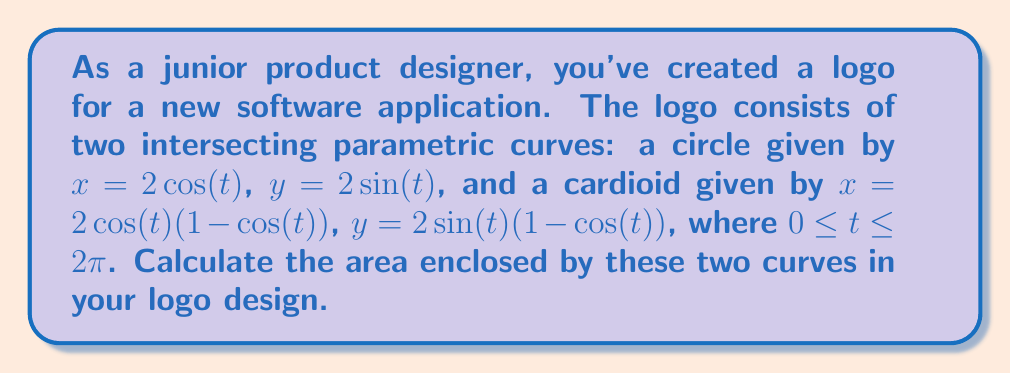Can you answer this question? To solve this problem, we'll follow these steps:

1) First, we need to find the points of intersection between the circle and the cardioid. These occur when:

   $2\cos(t) = 2\cos(t)(1-\cos(t))$
   $2\sin(t) = 2\sin(t)(1-\cos(t))$

   Solving these equations, we find that the curves intersect at $t = \frac{\pi}{3}$ and $t = \frac{5\pi}{3}$.

2) The area we're looking for is the difference between the area of the circle and the area of the cardioid that's outside the circle.

3) The area of the circle is straightforward:

   $A_{circle} = \pi r^2 = \pi(2^2) = 4\pi$

4) For the cardioid, we need to use the formula for area in polar coordinates:

   $A = \frac{1}{2} \int_0^{2\pi} r^2(\theta) d\theta$

   Where $r(\theta) = 2(1-\cos(\theta))$

5) Substituting this into our formula:

   $A_{cardioid} = \frac{1}{2} \int_0^{2\pi} (2(1-\cos(\theta)))^2 d\theta$
                 $= 2 \int_0^{2\pi} (1-2\cos(\theta)+\cos^2(\theta)) d\theta$
                 $= 2 [\theta - 2\sin(\theta) + \frac{\theta}{2} + \frac{\sin(2\theta)}{4}]_0^{2\pi}$
                 $= 2 [2\pi - 0 + \pi + 0] = 6\pi$

6) The area we want is the area of the circle minus the area of the cardioid outside the circle:

   $A_{logo} = A_{circle} + (A_{circle} - A_{cardioid})$
             $= 4\pi + (4\pi - 6\pi)$
             $= 2\pi$

Therefore, the area enclosed by the two curves in your logo design is $2\pi$ square units.
Answer: $2\pi$ square units 